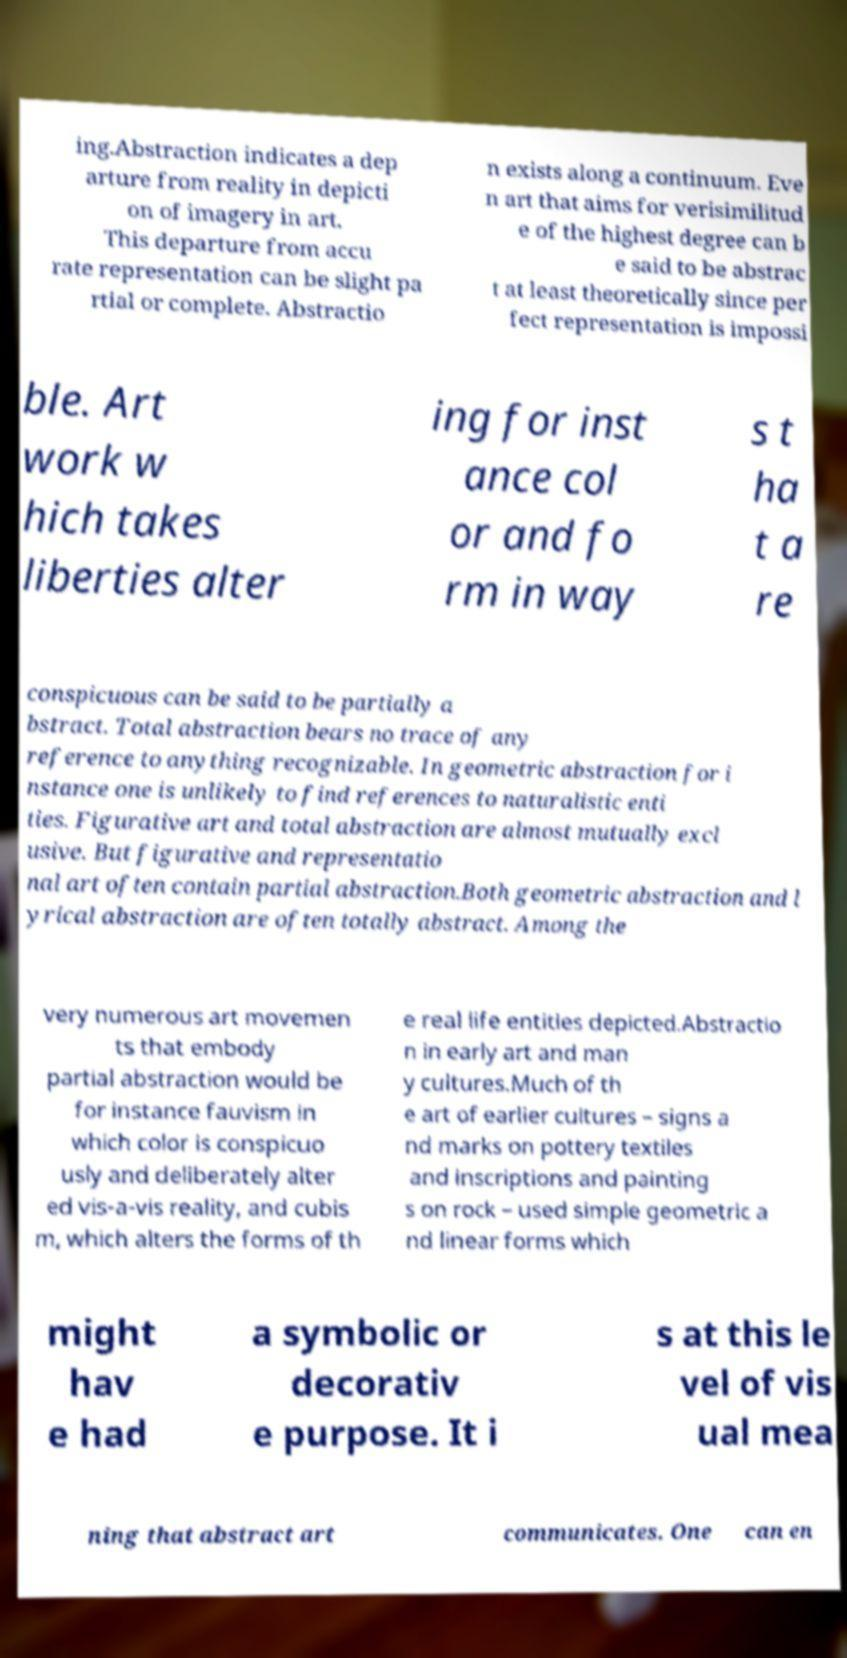What messages or text are displayed in this image? I need them in a readable, typed format. ing.Abstraction indicates a dep arture from reality in depicti on of imagery in art. This departure from accu rate representation can be slight pa rtial or complete. Abstractio n exists along a continuum. Eve n art that aims for verisimilitud e of the highest degree can b e said to be abstrac t at least theoretically since per fect representation is impossi ble. Art work w hich takes liberties alter ing for inst ance col or and fo rm in way s t ha t a re conspicuous can be said to be partially a bstract. Total abstraction bears no trace of any reference to anything recognizable. In geometric abstraction for i nstance one is unlikely to find references to naturalistic enti ties. Figurative art and total abstraction are almost mutually excl usive. But figurative and representatio nal art often contain partial abstraction.Both geometric abstraction and l yrical abstraction are often totally abstract. Among the very numerous art movemen ts that embody partial abstraction would be for instance fauvism in which color is conspicuo usly and deliberately alter ed vis-a-vis reality, and cubis m, which alters the forms of th e real life entities depicted.Abstractio n in early art and man y cultures.Much of th e art of earlier cultures – signs a nd marks on pottery textiles and inscriptions and painting s on rock – used simple geometric a nd linear forms which might hav e had a symbolic or decorativ e purpose. It i s at this le vel of vis ual mea ning that abstract art communicates. One can en 